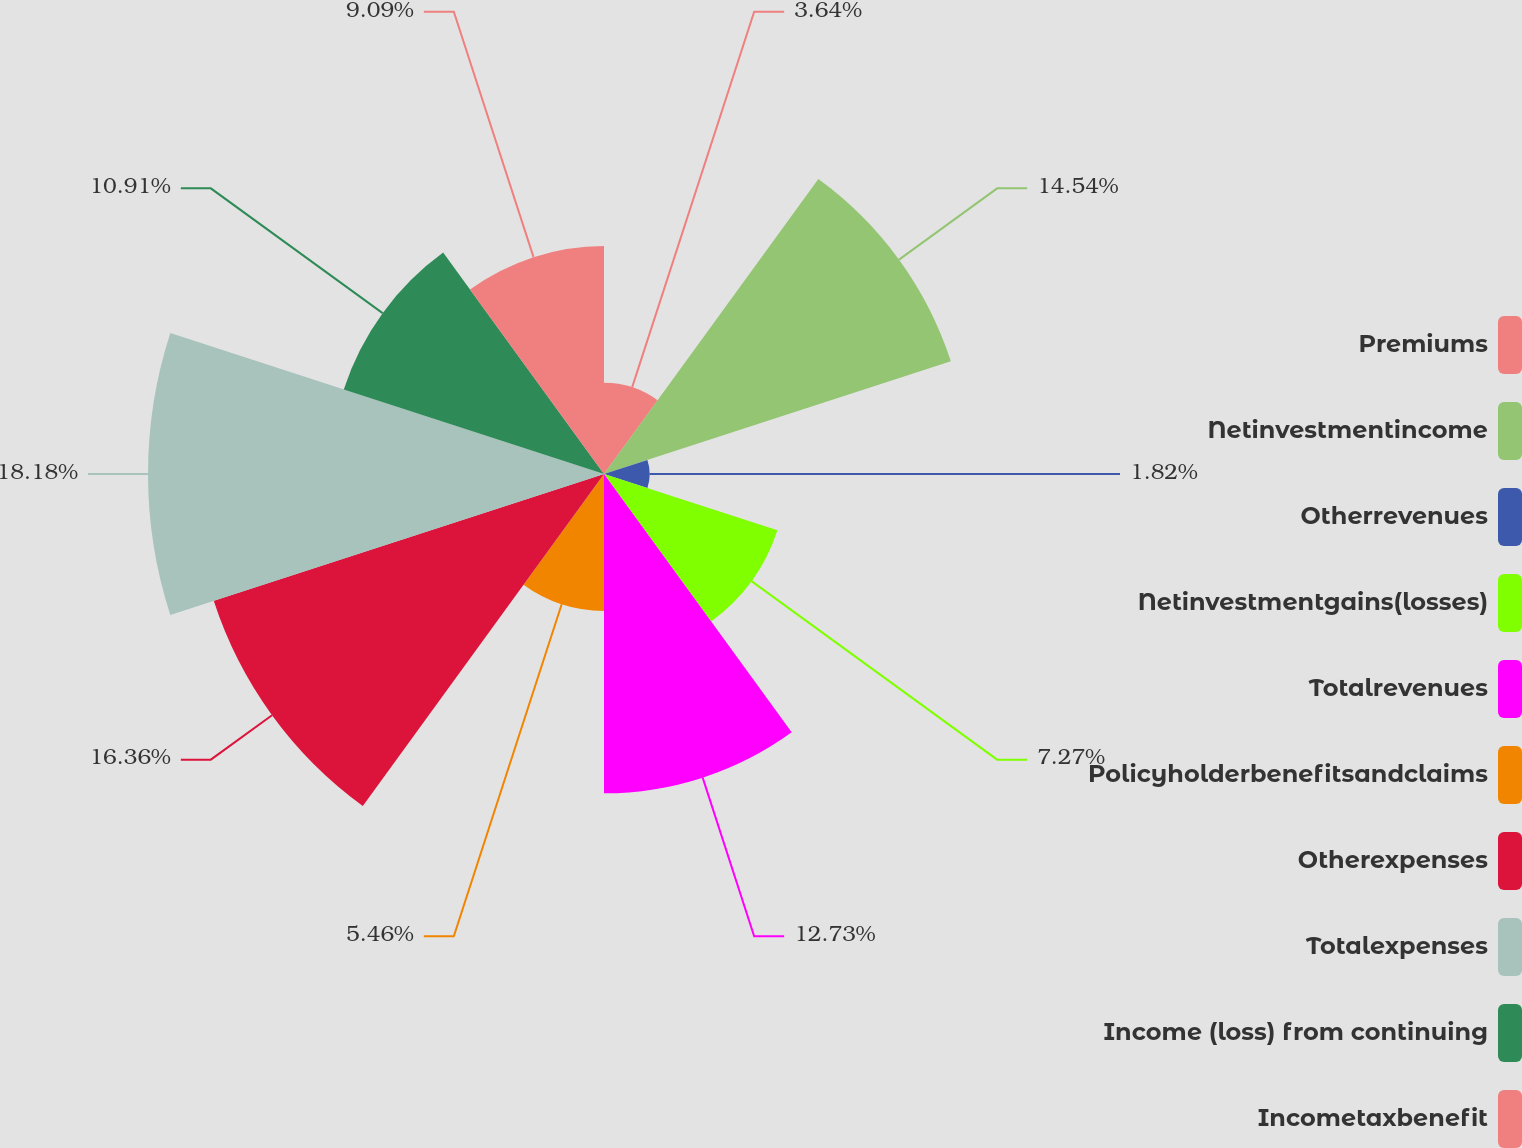<chart> <loc_0><loc_0><loc_500><loc_500><pie_chart><fcel>Premiums<fcel>Netinvestmentincome<fcel>Otherrevenues<fcel>Netinvestmentgains(losses)<fcel>Totalrevenues<fcel>Policyholderbenefitsandclaims<fcel>Otherexpenses<fcel>Totalexpenses<fcel>Income (loss) from continuing<fcel>Incometaxbenefit<nl><fcel>3.64%<fcel>14.54%<fcel>1.82%<fcel>7.27%<fcel>12.73%<fcel>5.46%<fcel>16.36%<fcel>18.18%<fcel>10.91%<fcel>9.09%<nl></chart> 